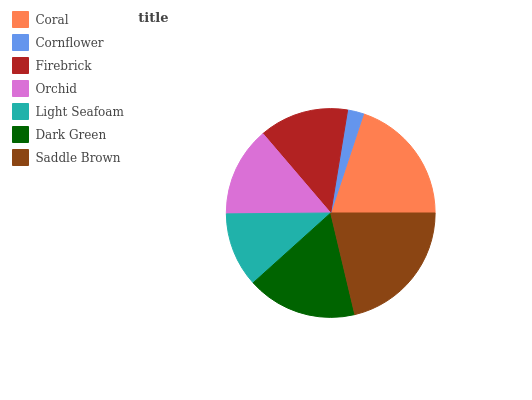Is Cornflower the minimum?
Answer yes or no. Yes. Is Saddle Brown the maximum?
Answer yes or no. Yes. Is Firebrick the minimum?
Answer yes or no. No. Is Firebrick the maximum?
Answer yes or no. No. Is Firebrick greater than Cornflower?
Answer yes or no. Yes. Is Cornflower less than Firebrick?
Answer yes or no. Yes. Is Cornflower greater than Firebrick?
Answer yes or no. No. Is Firebrick less than Cornflower?
Answer yes or no. No. Is Orchid the high median?
Answer yes or no. Yes. Is Orchid the low median?
Answer yes or no. Yes. Is Dark Green the high median?
Answer yes or no. No. Is Saddle Brown the low median?
Answer yes or no. No. 